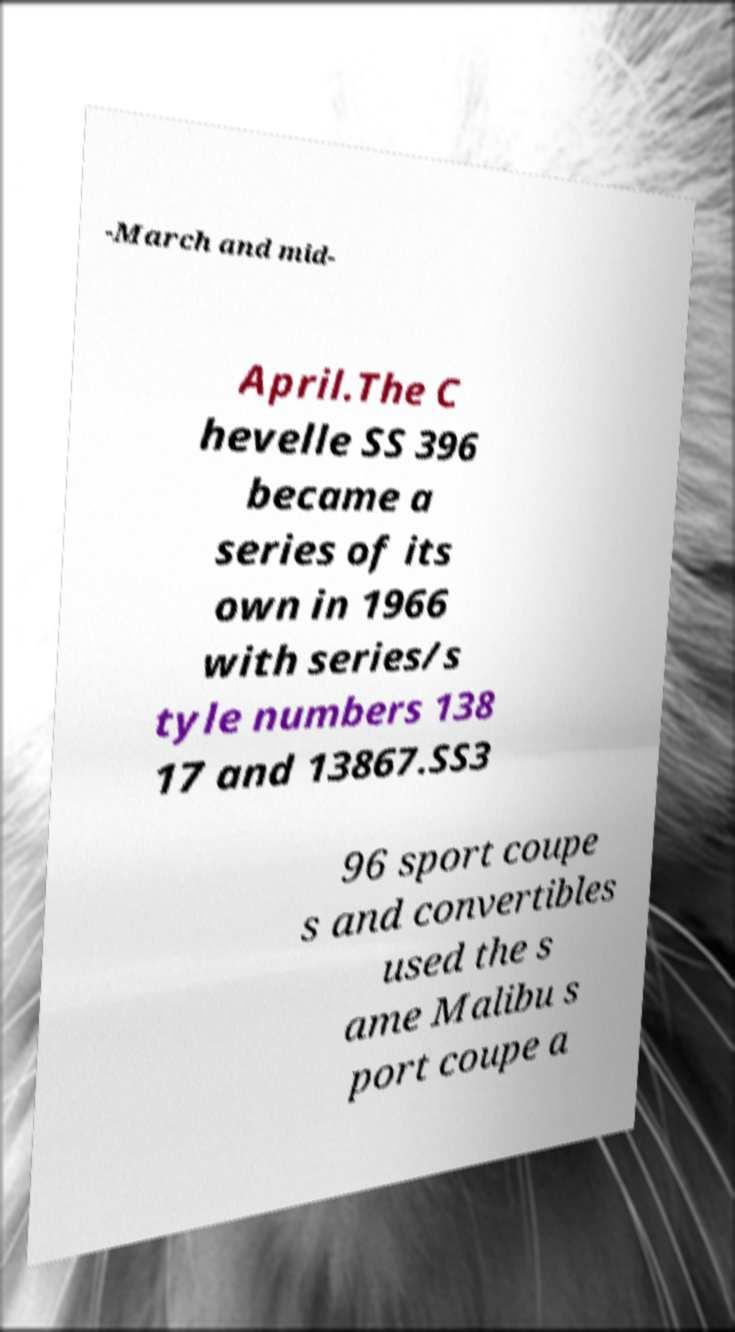I need the written content from this picture converted into text. Can you do that? -March and mid- April.The C hevelle SS 396 became a series of its own in 1966 with series/s tyle numbers 138 17 and 13867.SS3 96 sport coupe s and convertibles used the s ame Malibu s port coupe a 